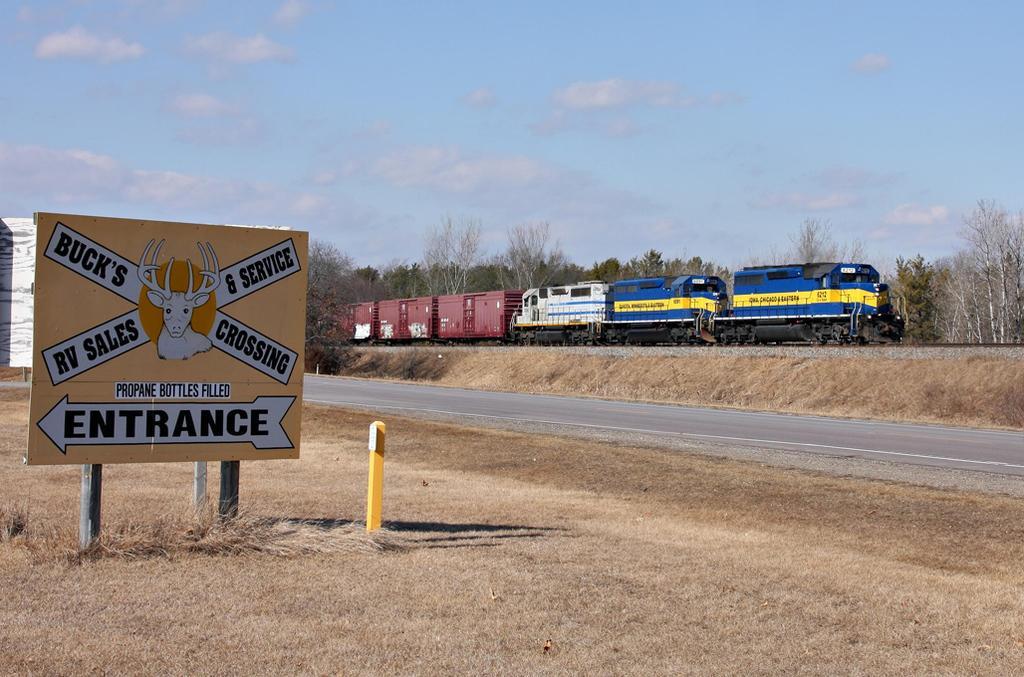Describe this image in one or two sentences. In this image there is a train in middle of this image and there are some trees in the background. there is a sign board at left side of this image and there is a road at bottom of this image and there is a sky at top of this image. There is some grass at bottom left side of this image. 